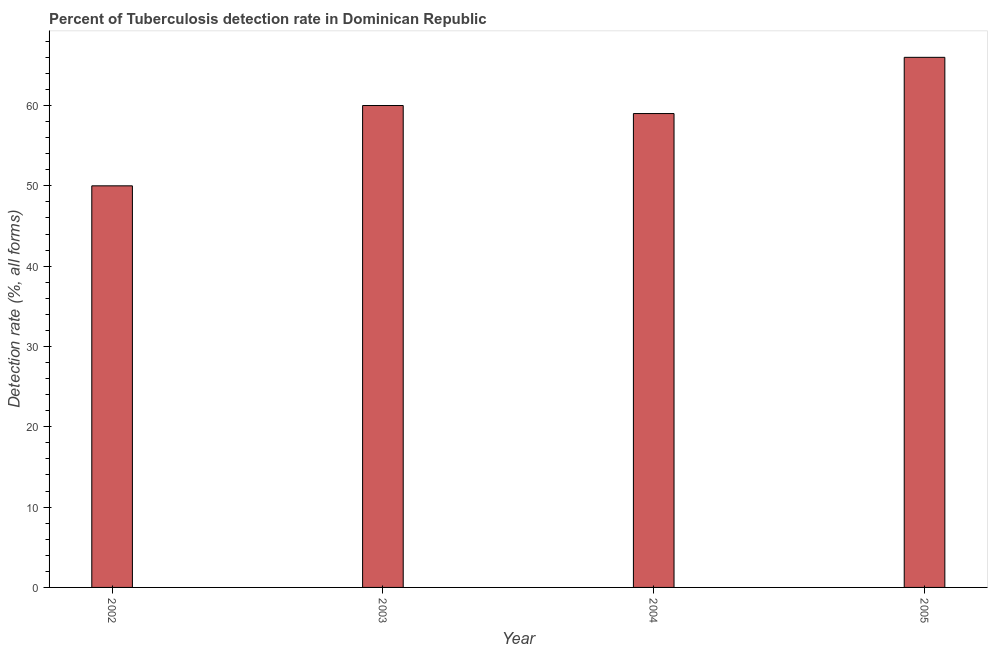Does the graph contain any zero values?
Your answer should be very brief. No. What is the title of the graph?
Your answer should be compact. Percent of Tuberculosis detection rate in Dominican Republic. What is the label or title of the Y-axis?
Make the answer very short. Detection rate (%, all forms). What is the detection rate of tuberculosis in 2003?
Give a very brief answer. 60. Across all years, what is the minimum detection rate of tuberculosis?
Your answer should be compact. 50. In which year was the detection rate of tuberculosis minimum?
Your answer should be compact. 2002. What is the sum of the detection rate of tuberculosis?
Keep it short and to the point. 235. What is the difference between the detection rate of tuberculosis in 2002 and 2005?
Provide a short and direct response. -16. What is the average detection rate of tuberculosis per year?
Your answer should be very brief. 58. What is the median detection rate of tuberculosis?
Your answer should be very brief. 59.5. In how many years, is the detection rate of tuberculosis greater than 34 %?
Provide a short and direct response. 4. Do a majority of the years between 2002 and 2003 (inclusive) have detection rate of tuberculosis greater than 42 %?
Ensure brevity in your answer.  Yes. What is the ratio of the detection rate of tuberculosis in 2004 to that in 2005?
Keep it short and to the point. 0.89. Are all the bars in the graph horizontal?
Your response must be concise. No. How many years are there in the graph?
Your response must be concise. 4. Are the values on the major ticks of Y-axis written in scientific E-notation?
Provide a short and direct response. No. What is the Detection rate (%, all forms) in 2003?
Ensure brevity in your answer.  60. What is the Detection rate (%, all forms) of 2005?
Ensure brevity in your answer.  66. What is the difference between the Detection rate (%, all forms) in 2002 and 2003?
Your answer should be compact. -10. What is the difference between the Detection rate (%, all forms) in 2003 and 2004?
Your answer should be compact. 1. What is the difference between the Detection rate (%, all forms) in 2003 and 2005?
Provide a succinct answer. -6. What is the difference between the Detection rate (%, all forms) in 2004 and 2005?
Make the answer very short. -7. What is the ratio of the Detection rate (%, all forms) in 2002 to that in 2003?
Give a very brief answer. 0.83. What is the ratio of the Detection rate (%, all forms) in 2002 to that in 2004?
Your answer should be very brief. 0.85. What is the ratio of the Detection rate (%, all forms) in 2002 to that in 2005?
Your response must be concise. 0.76. What is the ratio of the Detection rate (%, all forms) in 2003 to that in 2005?
Offer a terse response. 0.91. What is the ratio of the Detection rate (%, all forms) in 2004 to that in 2005?
Provide a short and direct response. 0.89. 